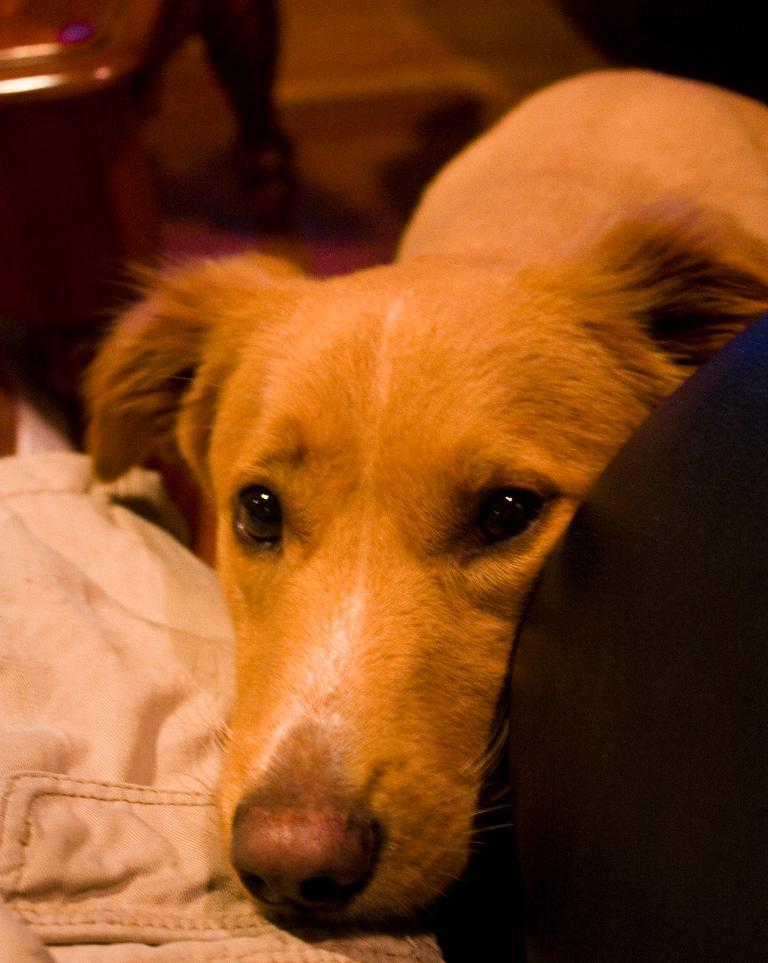What is the main subject in the center of the image? There is a dog in the center of the image. What colors of cloth can be seen on either side of the image? There is a white color cloth on the left side of the image and a black color cloth on the right side of the image. What type of rail can be seen in the image? There is no rail present in the image; it features a dog and two differently colored cloths. 